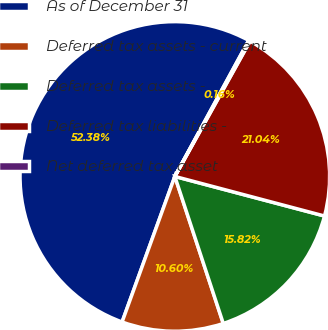Convert chart to OTSL. <chart><loc_0><loc_0><loc_500><loc_500><pie_chart><fcel>As of December 31<fcel>Deferred tax assets - current<fcel>Deferred tax assets -<fcel>Deferred tax liabilities -<fcel>Net deferred tax asset<nl><fcel>52.38%<fcel>10.6%<fcel>15.82%<fcel>21.04%<fcel>0.16%<nl></chart> 